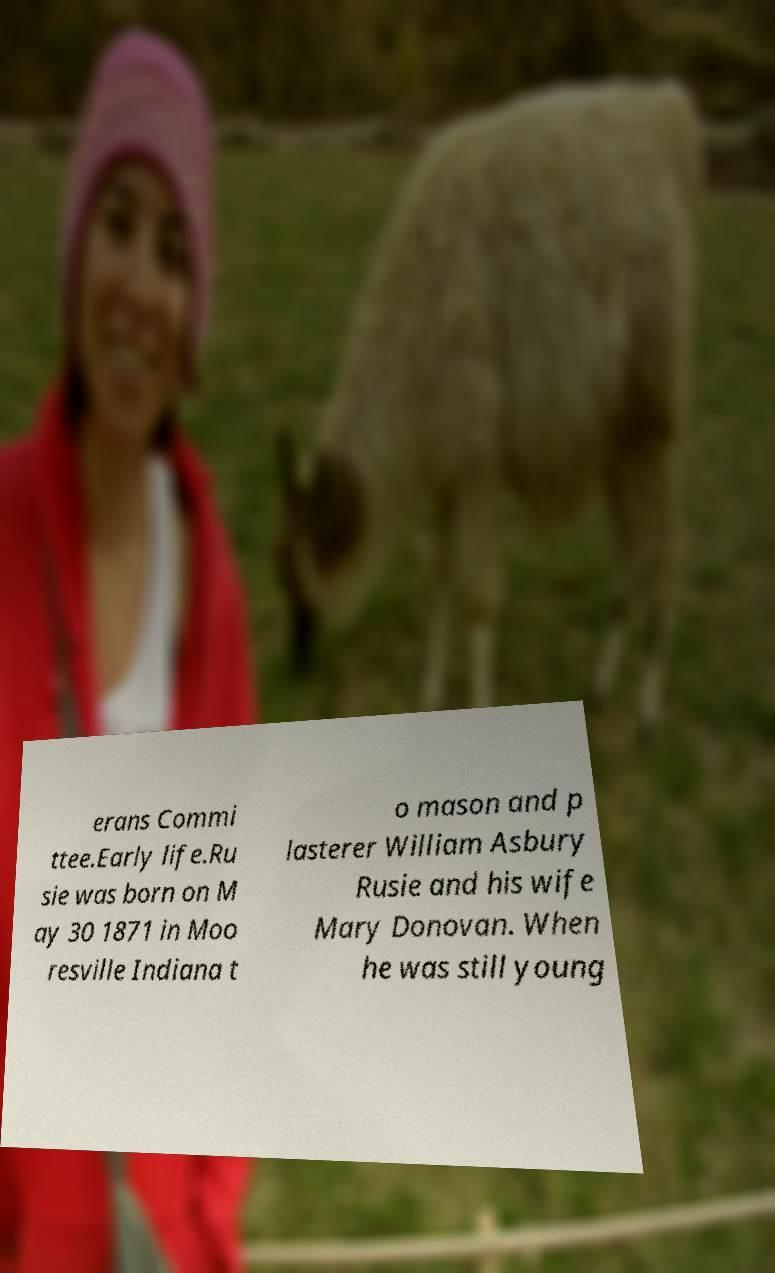There's text embedded in this image that I need extracted. Can you transcribe it verbatim? erans Commi ttee.Early life.Ru sie was born on M ay 30 1871 in Moo resville Indiana t o mason and p lasterer William Asbury Rusie and his wife Mary Donovan. When he was still young 